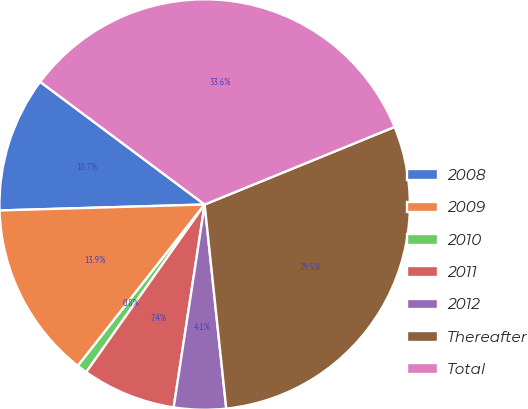Convert chart. <chart><loc_0><loc_0><loc_500><loc_500><pie_chart><fcel>2008<fcel>2009<fcel>2010<fcel>2011<fcel>2012<fcel>Thereafter<fcel>Total<nl><fcel>10.66%<fcel>13.94%<fcel>0.81%<fcel>7.38%<fcel>4.09%<fcel>29.49%<fcel>33.63%<nl></chart> 